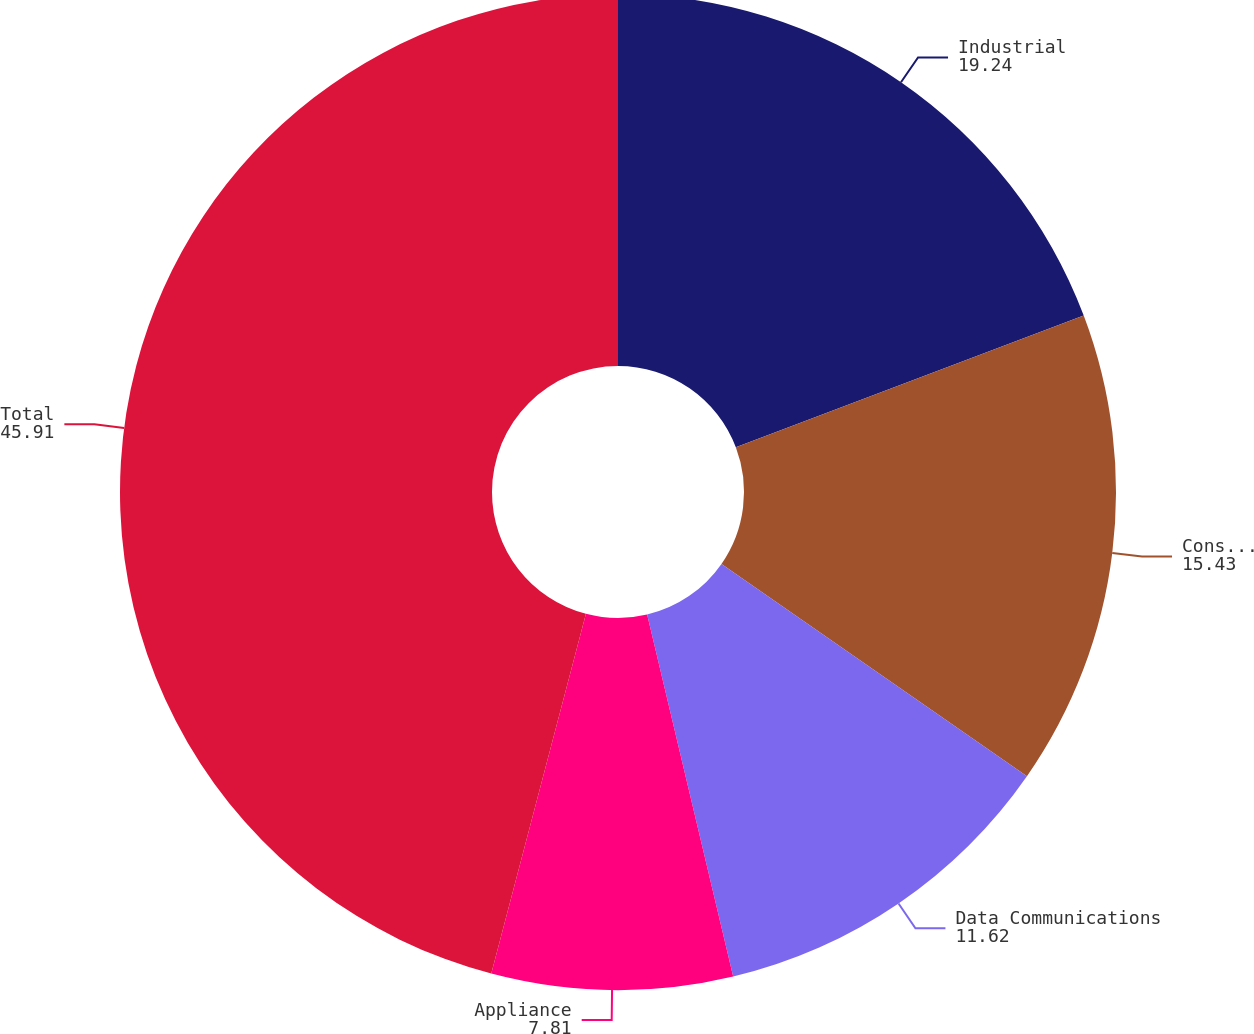<chart> <loc_0><loc_0><loc_500><loc_500><pie_chart><fcel>Industrial<fcel>Consumer Devices<fcel>Data Communications<fcel>Appliance<fcel>Total<nl><fcel>19.24%<fcel>15.43%<fcel>11.62%<fcel>7.81%<fcel>45.91%<nl></chart> 